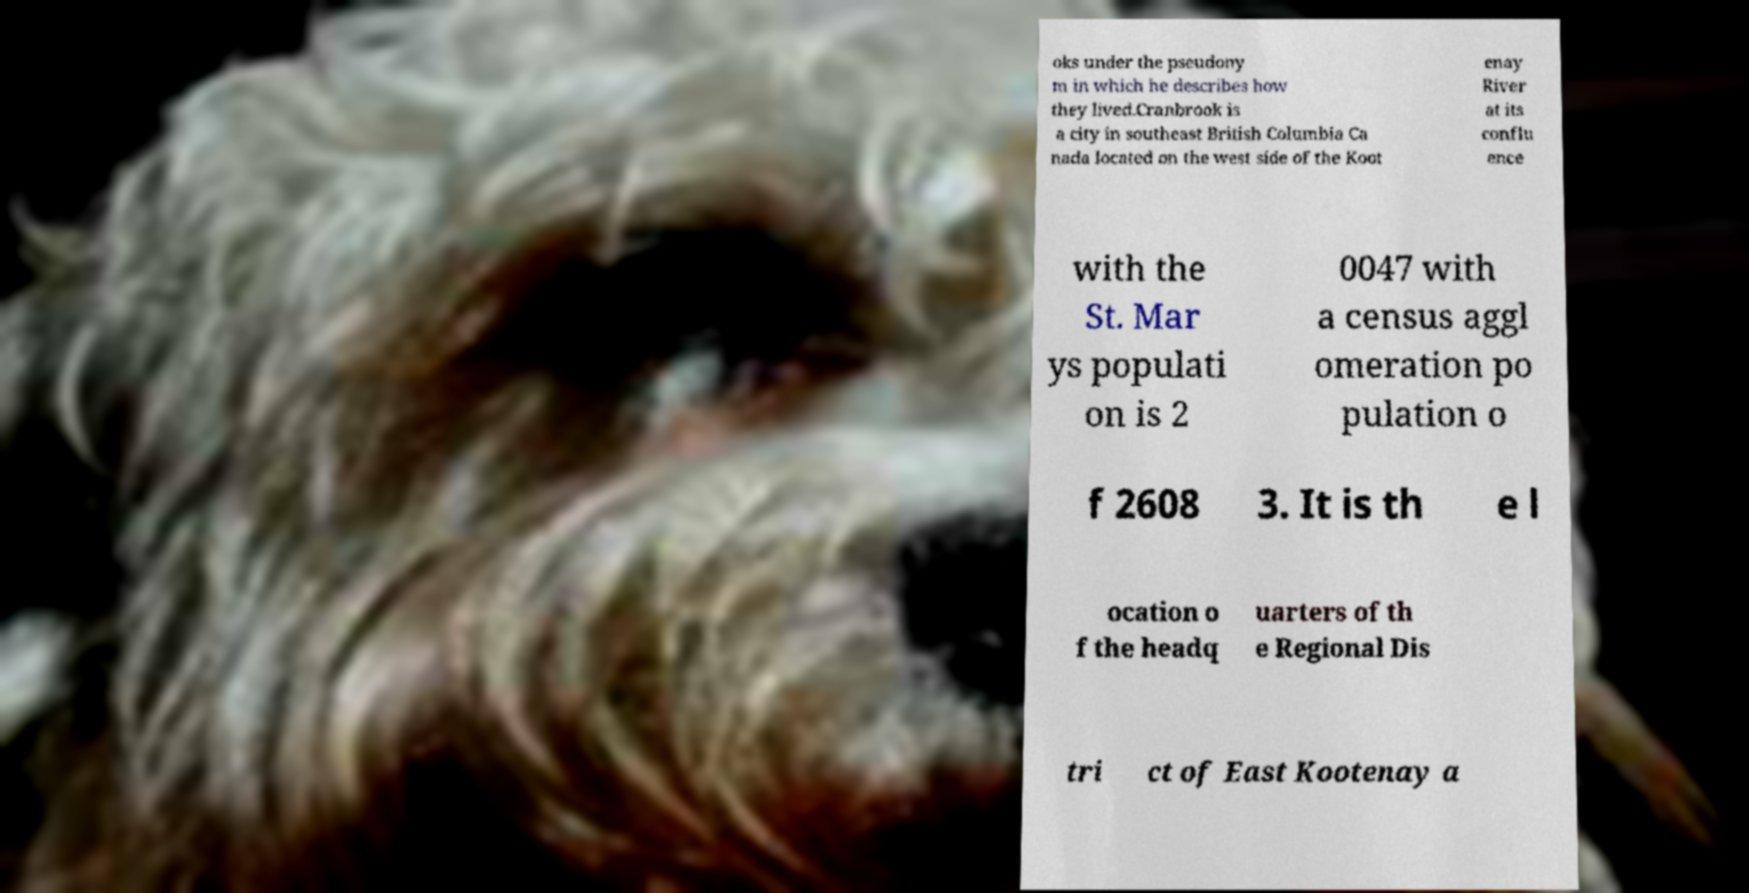For documentation purposes, I need the text within this image transcribed. Could you provide that? oks under the pseudony m in which he describes how they lived.Cranbrook is a city in southeast British Columbia Ca nada located on the west side of the Koot enay River at its conflu ence with the St. Mar ys populati on is 2 0047 with a census aggl omeration po pulation o f 2608 3. It is th e l ocation o f the headq uarters of th e Regional Dis tri ct of East Kootenay a 